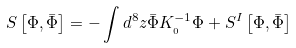<formula> <loc_0><loc_0><loc_500><loc_500>S \left [ \Phi , \bar { \Phi } \right ] = - \int d ^ { 8 } z \bar { \Phi } K _ { \L _ { 0 } } ^ { - 1 } \Phi + S ^ { I } \left [ \Phi , \bar { \Phi } \right ]</formula> 